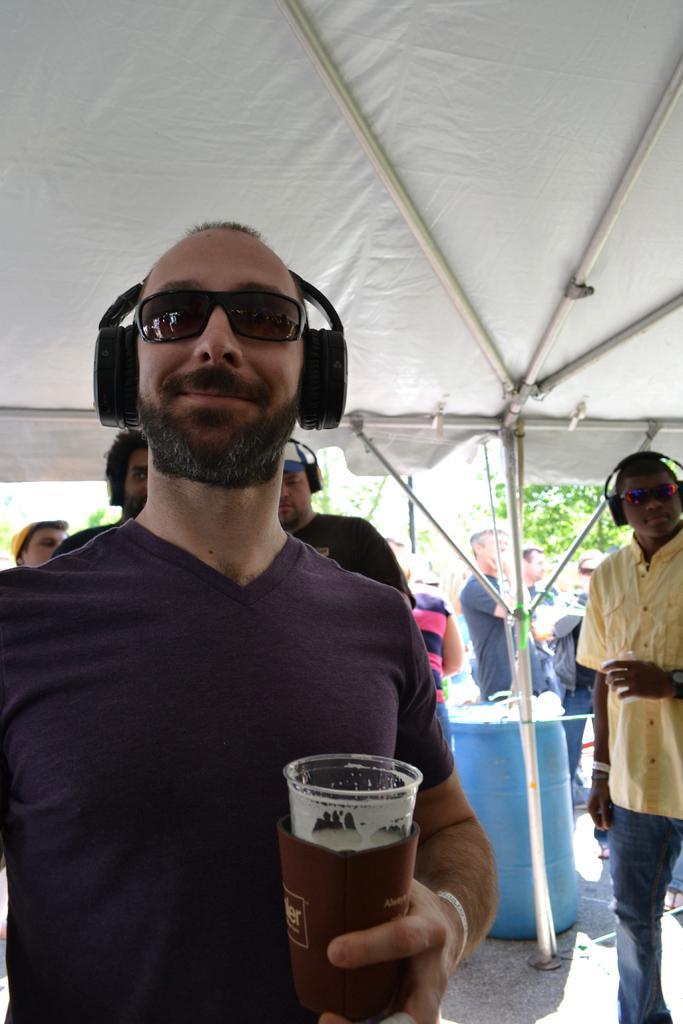Please provide a concise description of this image. In this image I can see few people standing. In front the man is wearing a headset and a glasses and holding a glass. At the back side I can see a drums and a trees. 